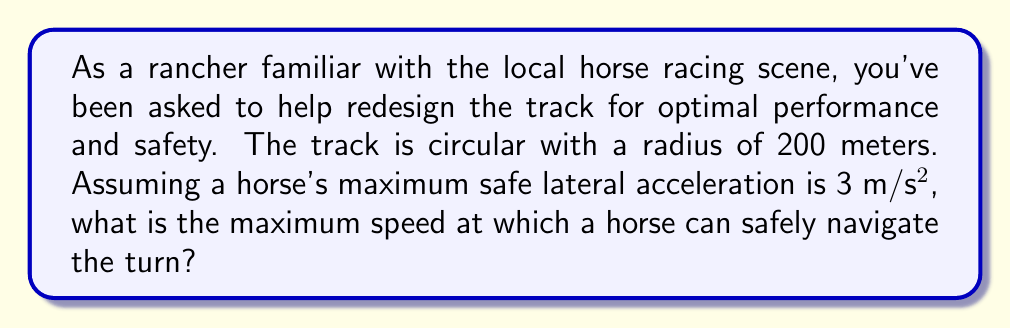Help me with this question. Let's approach this step-by-step using concepts from differential geometry and physics:

1) The curvature ($\kappa$) of a circle is the reciprocal of its radius ($R$):

   $$\kappa = \frac{1}{R} = \frac{1}{200} \text{ m}^{-1}$$

2) In circular motion, the centripetal acceleration ($a_c$) is related to the velocity ($v$) and radius ($R$) by:

   $$a_c = \frac{v^2}{R}$$

3) We're given that the maximum safe lateral acceleration is 3 m/s². This is our centripetal acceleration:

   $$a_c = 3 \text{ m/s}^2$$

4) Substituting this into the centripetal acceleration equation:

   $$3 = \frac{v^2}{200}$$

5) Solving for $v$:

   $$v^2 = 3 \times 200 = 600$$
   $$v = \sqrt{600} = 24.49 \text{ m/s}$$

6) Converting to km/h for a more familiar unit:

   $$24.49 \text{ m/s} \times \frac{3600 \text{ s}}{1 \text{ h}} \times \frac{1 \text{ km}}{1000 \text{ m}} = 88.17 \text{ km/h}$$

Therefore, the maximum safe speed for a horse on this track is approximately 88.17 km/h.
Answer: 88.17 km/h 